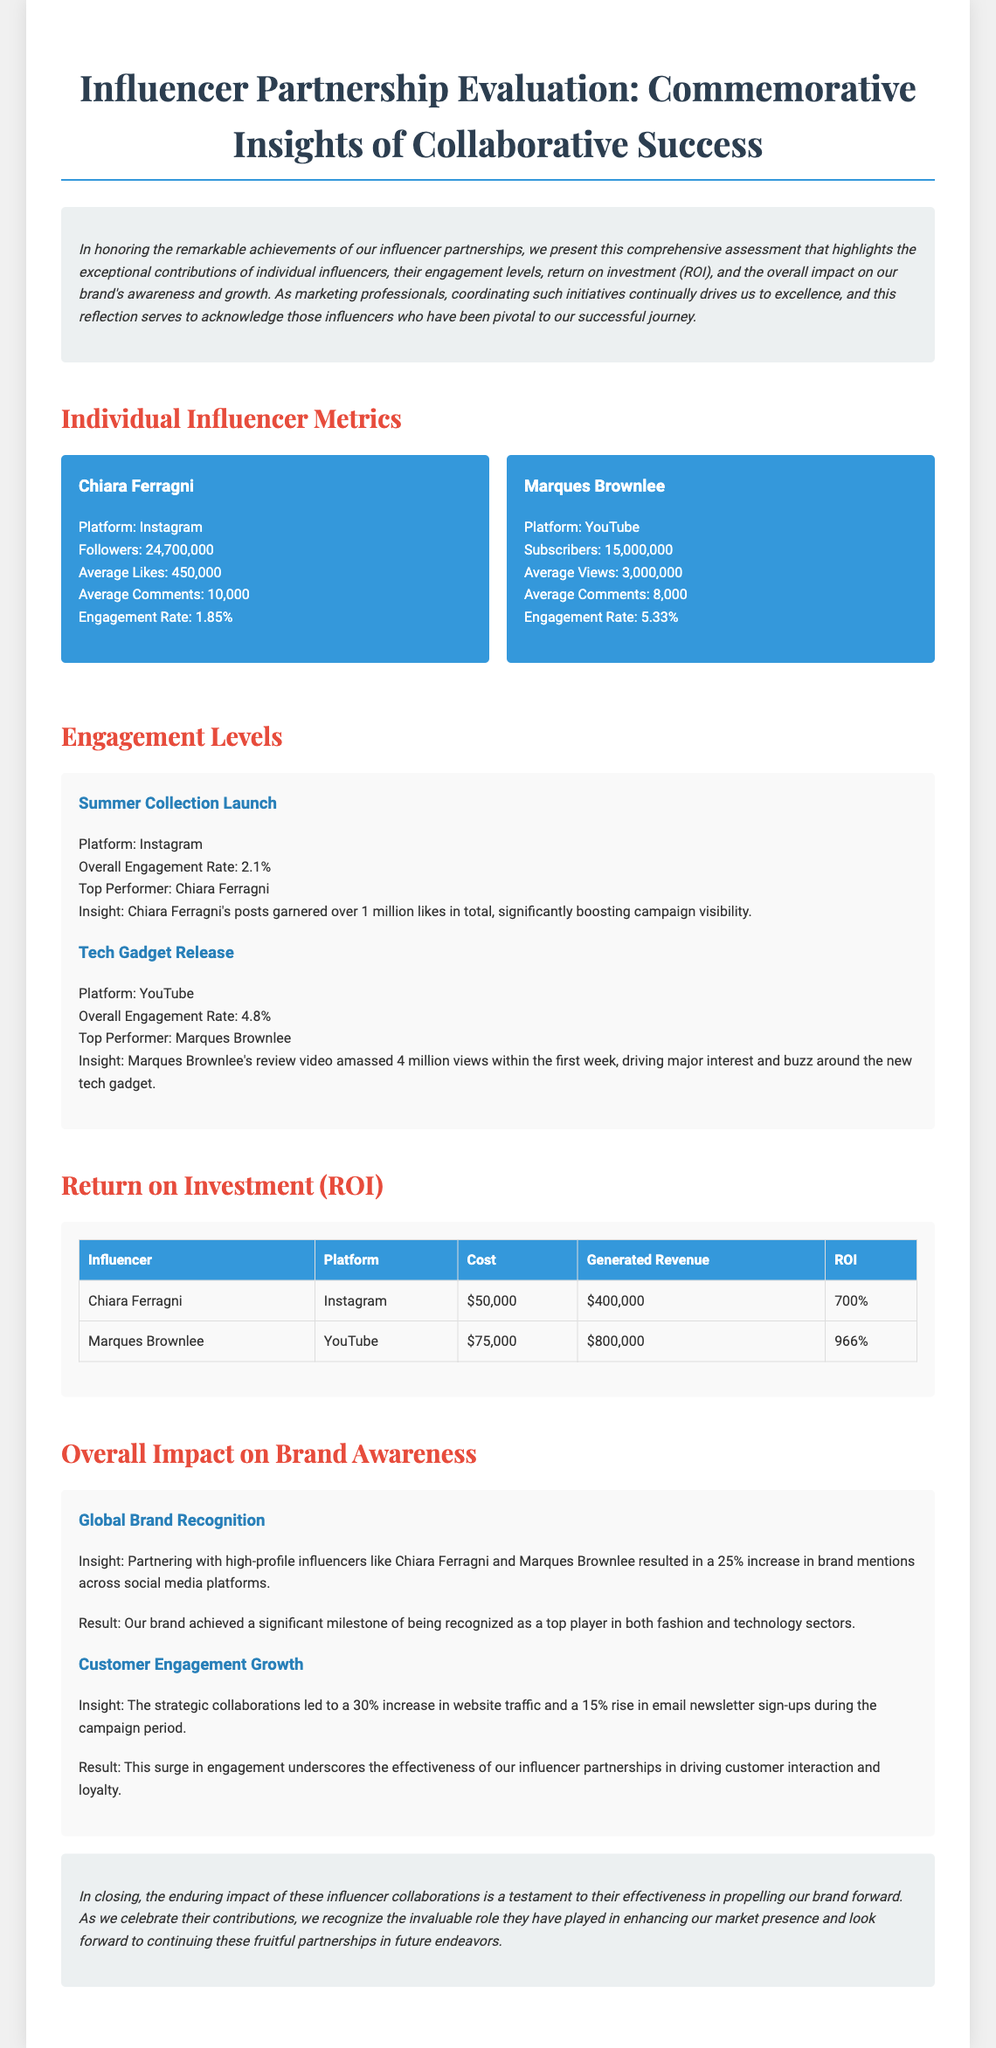What is the engagement rate for Chiara Ferragni? The engagement rate for Chiara Ferragni is mentioned in her metrics section of the document as 1.85%.
Answer: 1.85% What was the generated revenue from Marques Brownlee's collaboration? The document states that the generated revenue from Marques Brownlee's collaboration is $800,000 as listed in the ROI section.
Answer: $800,000 Which influencer had the highest engagement rate? The engagement rates for both influencers indicate that Marques Brownlee had the highest engagement rate of 5.33%.
Answer: Marques Brownlee By what percentage did brand mentions increase due to influencer partnerships? The document highlights a 25% increase in brand mentions across social media platforms due to influencer partnerships.
Answer: 25% What was the cost of the partnership with Chiara Ferragni? The document lists the cost of the partnership with Chiara Ferragni as $50,000 in the ROI section.
Answer: $50,000 What platform did Chiara Ferragni use for her partnership? The document specifies that Chiara Ferragni used Instagram for her partnership.
Answer: Instagram What was the overall engagement rate for the Summer Collection Launch? The document provides the overall engagement rate for the Summer Collection Launch as 2.1%.
Answer: 2.1% What insight was gained from the Tech Gadget Release? The insight from the Tech Gadget Release indicates that Marques Brownlee's review video amassed 4 million views within the first week.
Answer: 4 million views What is the primary focus of this document? The primary focus of the document is to evaluate influencer partnerships and their impact on brand awareness through comprehensive metrics.
Answer: Evaluate influencer partnerships 